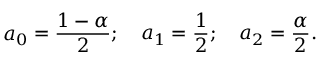Convert formula to latex. <formula><loc_0><loc_0><loc_500><loc_500>a _ { 0 } = { \frac { 1 - \alpha } { 2 } } ; \quad a _ { 1 } = { \frac { 1 } { 2 } } ; \quad a _ { 2 } = { \frac { \alpha } { 2 } } .</formula> 